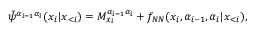Convert formula to latex. <formula><loc_0><loc_0><loc_500><loc_500>\tilde { \psi } ^ { \alpha _ { i - 1 } \alpha _ { i } } ( x _ { i } | \boldsymbol x _ { < i } ) = M _ { x _ { i } } ^ { \alpha _ { i - 1 } \alpha _ { i } } + f _ { N N } ( x _ { i } , \alpha _ { i - 1 } , \alpha _ { i } | \boldsymbol x _ { < i } ) ,</formula> 